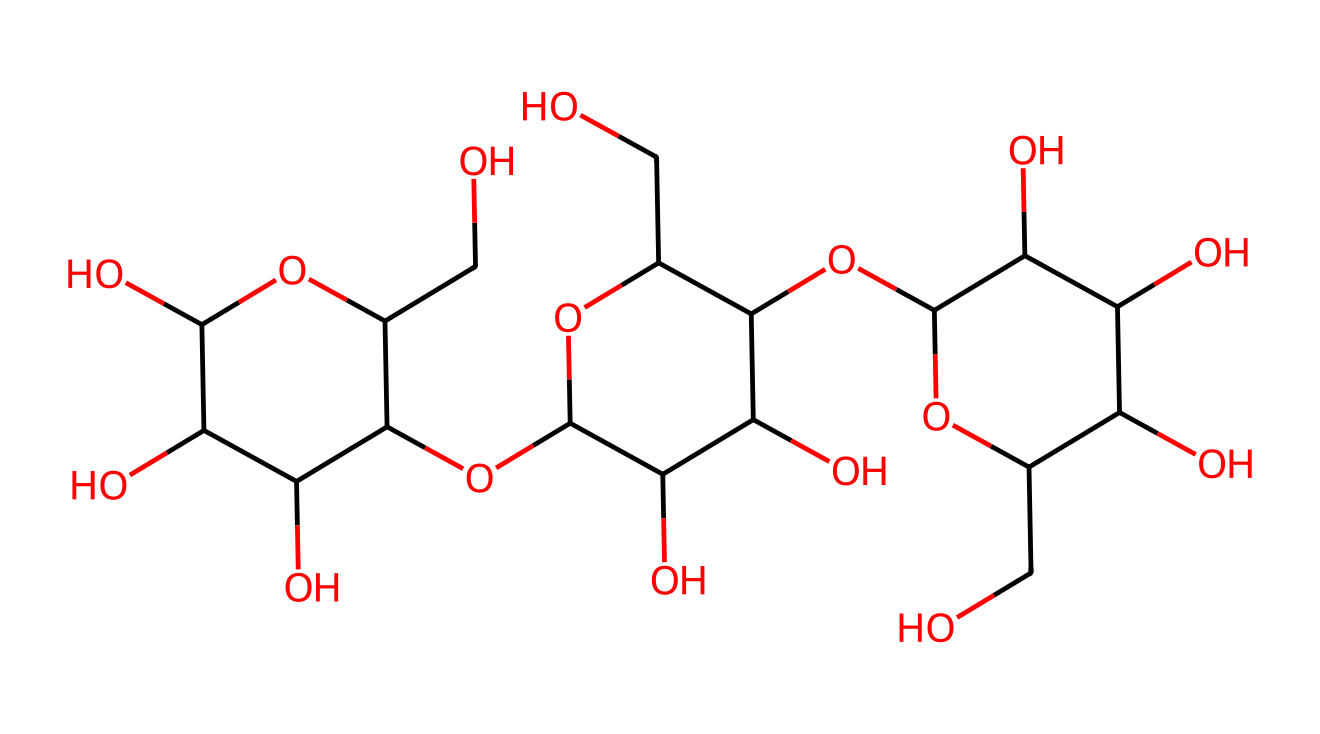What is the primary building block of this chemical structure? The chemical structure represents cellulose, which is made up of repeating glucose units connected by glycosidic bonds. The repeating unit visible in the structure is glucose.
Answer: glucose How many carbon atoms are in this cellulose molecular structure? Counting all the carbon (C) atoms from the SMILES representation, there are 6 carbon atoms in each of the repeating glucose units, and there are multiple units in this structure. In total, there are 12 carbon atoms.
Answer: 12 What type of molecule is represented by this structure? The structure represents a polysaccharide as it consists of long chains of monosaccharides (glucose) linked together.
Answer: polysaccharide How many hydroxyl (–OH) groups are present in this structure? By examining the structure, each glucose unit contributes multiple hydroxyl groups. In total, the structure contains 8 hydroxyl groups.
Answer: 8 What kind of bonding connects the glucose units in this cellulose structure? The glucose units are connected by β-1,4-glycosidic bonds, which are typical for cellulose.
Answer: β-1,4-glycosidic bonds What is the significance of the branching in this structure? The structure represents a linear arrangement of glucose, characteristic of cellulose, which is not branched like some other polysaccharides (e.g., glycogen). This linearity contributes to the strong hydrogen bonding between fibers, giving cellulose its structural strength.
Answer: linear arrangement 